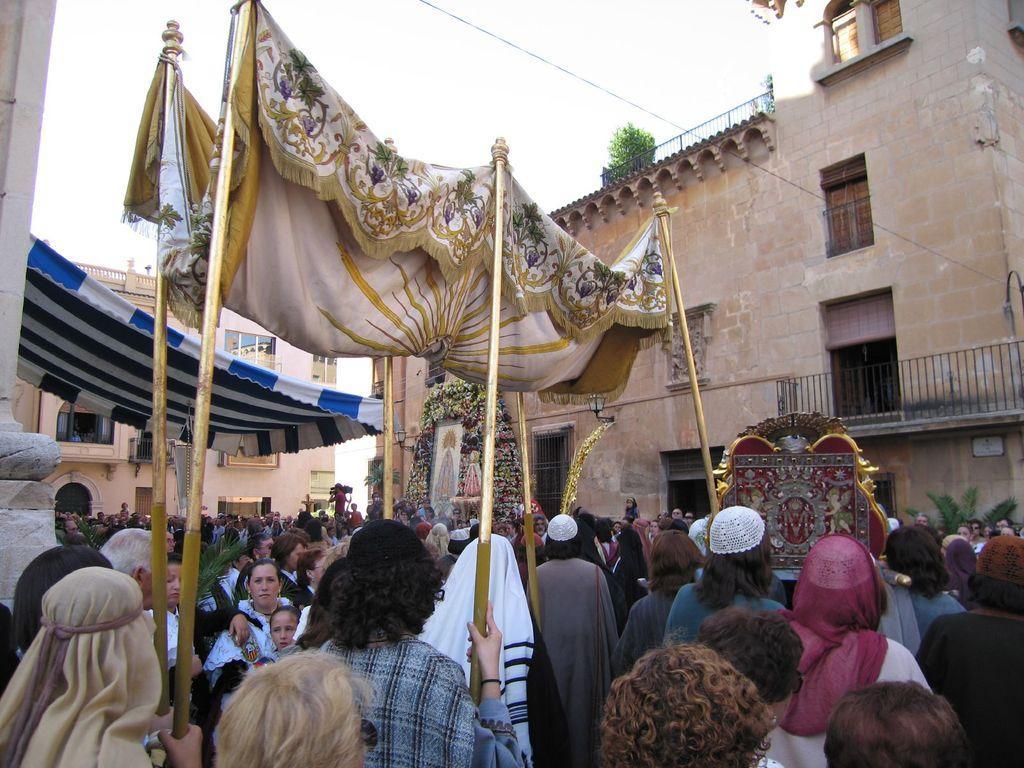Can you describe this image briefly? At the bottom of the image there are many people standing. There are few people holding poles with cloth. In the background there are buildings with walls, windows and railings. And also there are trees. 